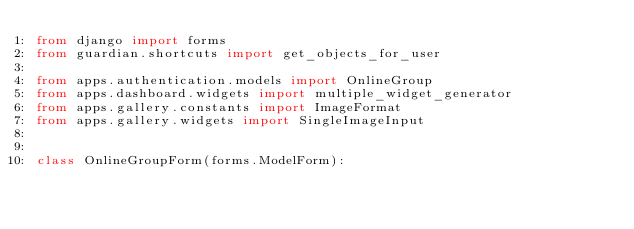<code> <loc_0><loc_0><loc_500><loc_500><_Python_>from django import forms
from guardian.shortcuts import get_objects_for_user

from apps.authentication.models import OnlineGroup
from apps.dashboard.widgets import multiple_widget_generator
from apps.gallery.constants import ImageFormat
from apps.gallery.widgets import SingleImageInput


class OnlineGroupForm(forms.ModelForm):</code> 